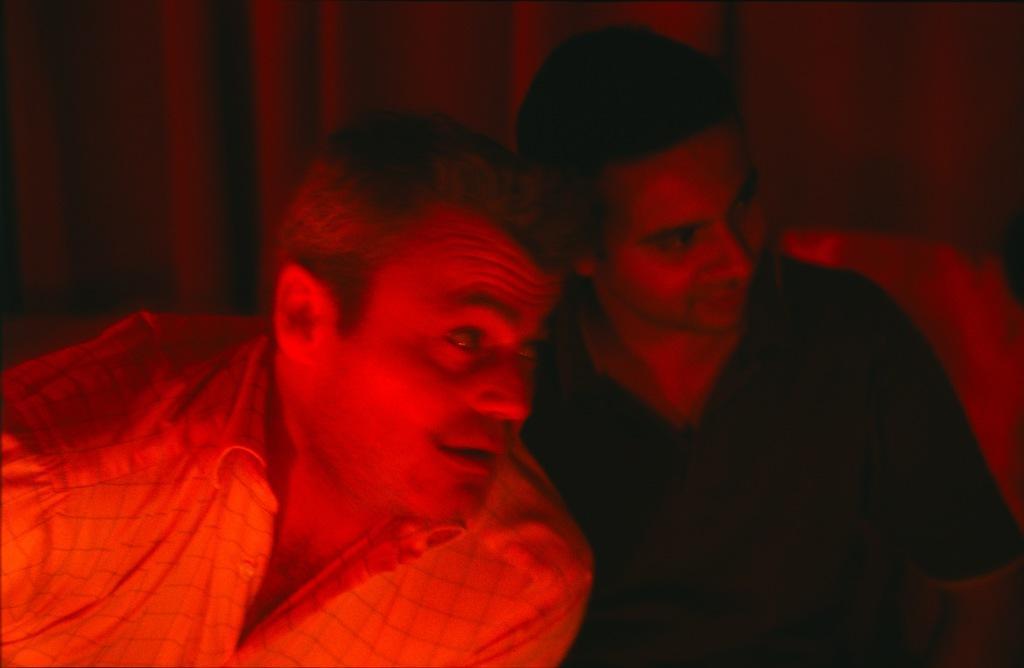Could you give a brief overview of what you see in this image? In the foreground of this image, there is a red light on two men and the background image is not clear. 